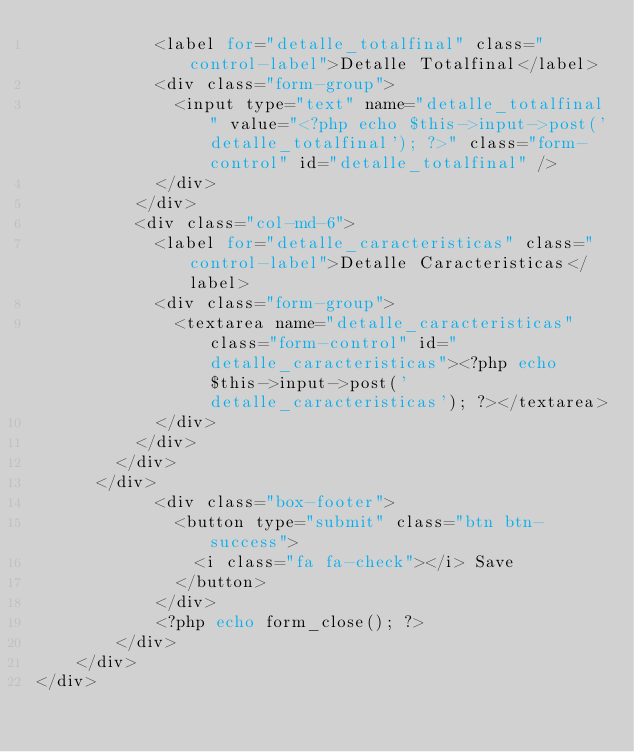Convert code to text. <code><loc_0><loc_0><loc_500><loc_500><_PHP_>						<label for="detalle_totalfinal" class="control-label">Detalle Totalfinal</label>
						<div class="form-group">
							<input type="text" name="detalle_totalfinal" value="<?php echo $this->input->post('detalle_totalfinal'); ?>" class="form-control" id="detalle_totalfinal" />
						</div>
					</div>
					<div class="col-md-6">
						<label for="detalle_caracteristicas" class="control-label">Detalle Caracteristicas</label>
						<div class="form-group">
							<textarea name="detalle_caracteristicas" class="form-control" id="detalle_caracteristicas"><?php echo $this->input->post('detalle_caracteristicas'); ?></textarea>
						</div>
					</div>
				</div>
			</div>
          	<div class="box-footer">
            	<button type="submit" class="btn btn-success">
            		<i class="fa fa-check"></i> Save
            	</button>
          	</div>
            <?php echo form_close(); ?>
      	</div>
    </div>
</div></code> 